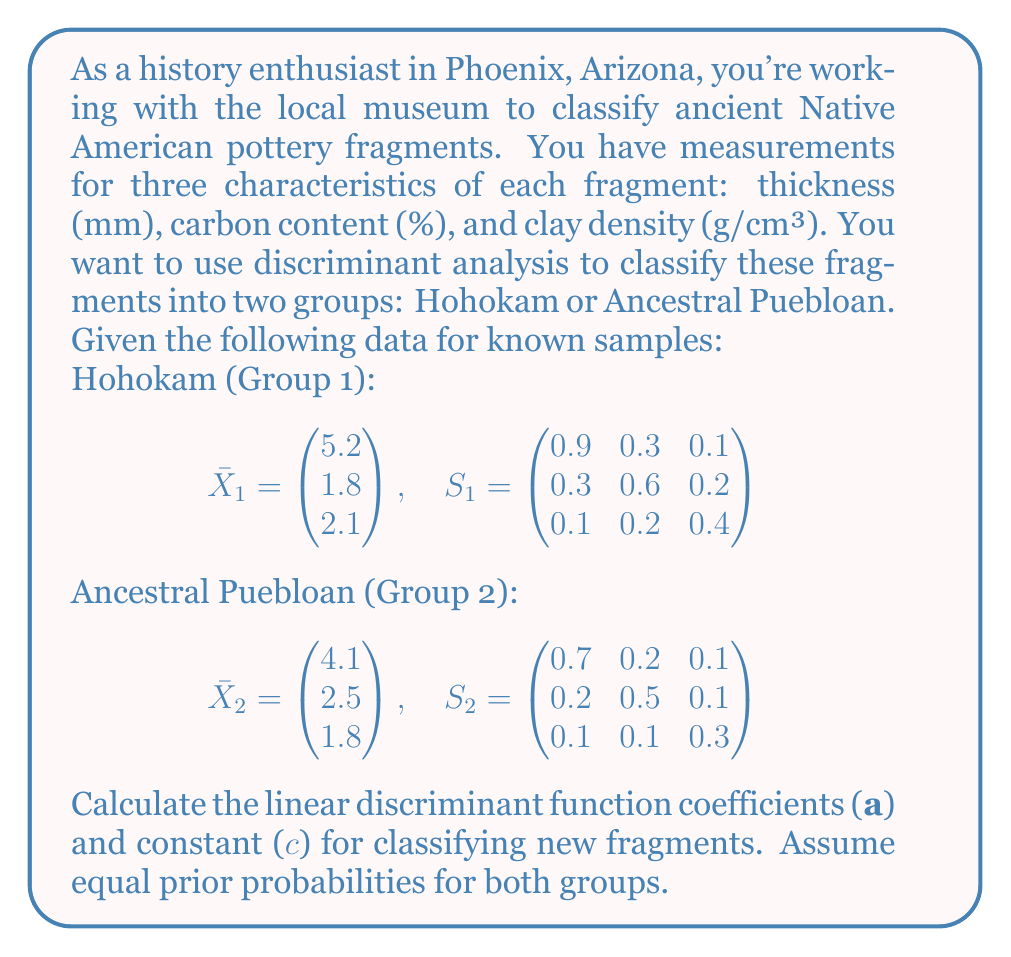Teach me how to tackle this problem. To solve this problem, we'll follow these steps:

1) Calculate the pooled covariance matrix $S_p$:
   $$S_p = \frac{1}{2}(S_1 + S_2) = \begin{pmatrix} 0.8 & 0.25 & 0.1 \\ 0.25 & 0.55 & 0.15 \\ 0.1 & 0.15 & 0.35 \end{pmatrix}$$

2) Calculate $S_p^{-1}$:
   $$S_p^{-1} = \begin{pmatrix} 1.4286 & -0.5714 & -0.1429 \\ -0.5714 & 2.1429 & -0.5714 \\ -0.1429 & -0.5714 & 3.1429 \end{pmatrix}$$

3) Calculate the coefficient vector $a$:
   $$a = S_p^{-1}(\bar{X}_1 - \bar{X}_2)$$
   
   $$a = \begin{pmatrix} 1.4286 & -0.5714 & -0.1429 \\ -0.5714 & 2.1429 & -0.5714 \\ -0.1429 & -0.5714 & 3.1429 \end{pmatrix} \begin{pmatrix} 1.1 \\ -0.7 \\ 0.3 \end{pmatrix}$$
   
   $$a = \begin{pmatrix} 2.0000 \\ -2.2857 \\ 1.1429 \end{pmatrix}$$

4) Calculate the constant $c$:
   $$c = -\frac{1}{2}a'(\bar{X}_1 + \bar{X}_2)$$
   
   $$c = -\frac{1}{2}(2.0000, -2.2857, 1.1429)\begin{pmatrix} 4.65 \\ 2.15 \\ 1.95 \end{pmatrix}$$
   
   $$c = -0.9643$$

The linear discriminant function is:
$$D(X) = a'X + c = 2.0000x_1 - 2.2857x_2 + 1.1429x_3 - 0.9643$$

Where $x_1$ is thickness, $x_2$ is carbon content, and $x_3$ is clay density.
Answer: $a = (2.0000, -2.2857, 1.1429)$, $c = -0.9643$ 